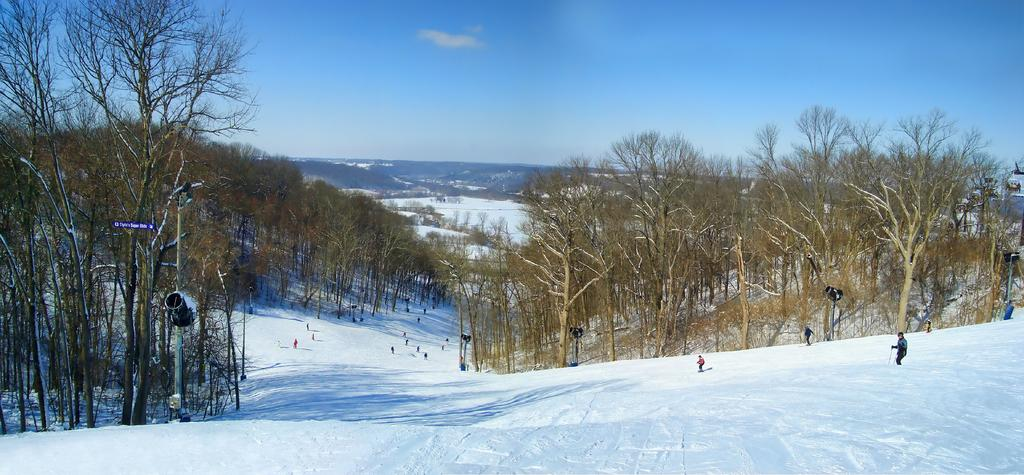What activity are the people in the image engaged in? The people in the image are skiing. What surface are they skiing on? They are skiing on snow. What objects can be seen in the image that are related to skiing? There are poles visible in the image. What type of natural environment is present in the image? There are trees in the image. Can you tell me how many trains are passing through the middle of the image? There are no trains present in the image; it features people skiing in a forest. What type of hook is being used by the skiers in the image? There is no hook visible in the image; the skiers are using ski poles. 